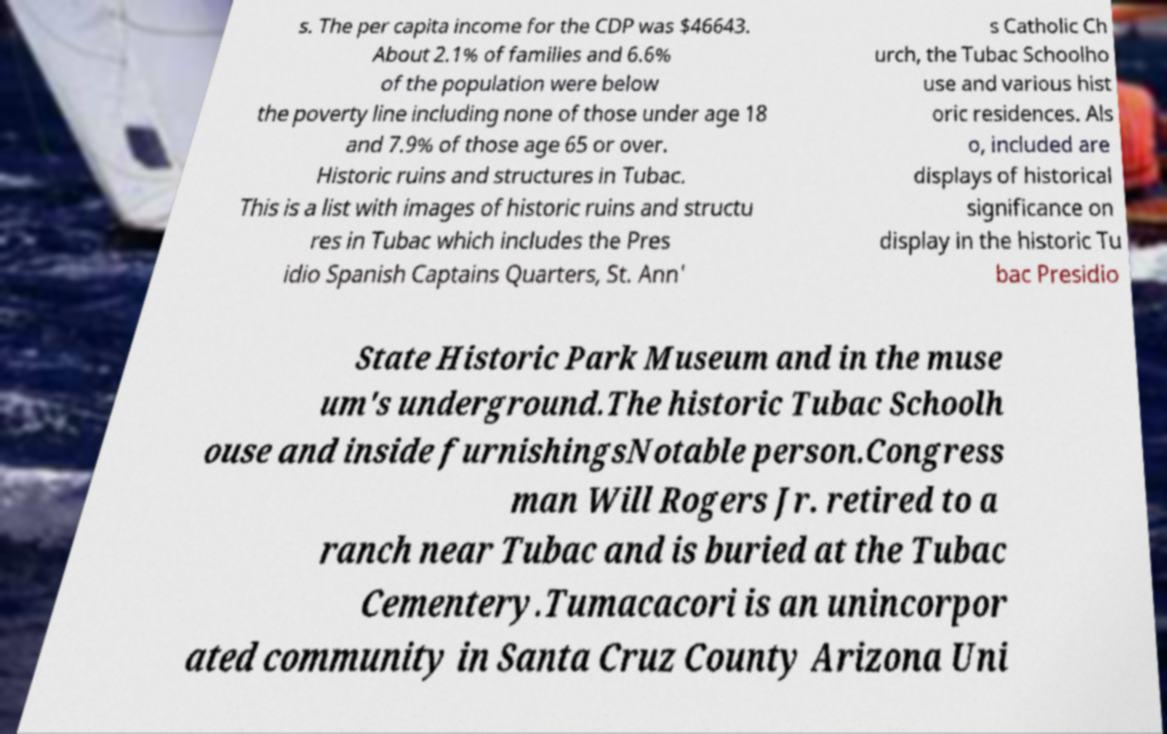I need the written content from this picture converted into text. Can you do that? s. The per capita income for the CDP was $46643. About 2.1% of families and 6.6% of the population were below the poverty line including none of those under age 18 and 7.9% of those age 65 or over. Historic ruins and structures in Tubac. This is a list with images of historic ruins and structu res in Tubac which includes the Pres idio Spanish Captains Quarters, St. Ann' s Catholic Ch urch, the Tubac Schoolho use and various hist oric residences. Als o, included are displays of historical significance on display in the historic Tu bac Presidio State Historic Park Museum and in the muse um's underground.The historic Tubac Schoolh ouse and inside furnishingsNotable person.Congress man Will Rogers Jr. retired to a ranch near Tubac and is buried at the Tubac Cementery.Tumacacori is an unincorpor ated community in Santa Cruz County Arizona Uni 